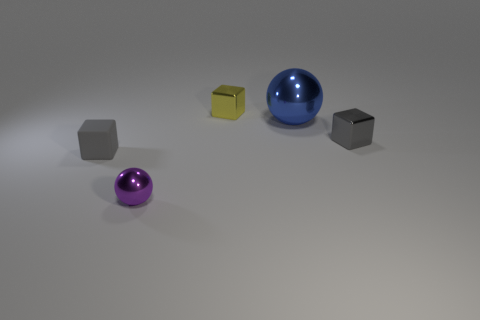Add 3 gray rubber things. How many objects exist? 8 Subtract all balls. How many objects are left? 3 Subtract 0 cyan balls. How many objects are left? 5 Subtract all balls. Subtract all tiny gray metal things. How many objects are left? 2 Add 3 small gray shiny objects. How many small gray shiny objects are left? 4 Add 5 rubber objects. How many rubber objects exist? 6 